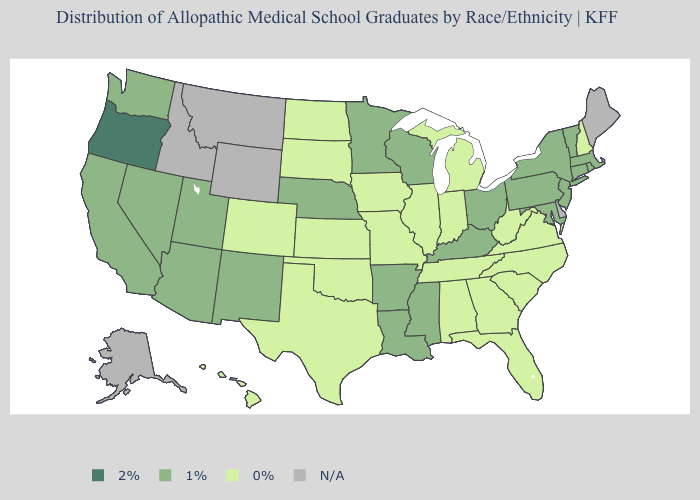What is the highest value in the USA?
Write a very short answer. 2%. What is the lowest value in the Northeast?
Be succinct. 0%. What is the value of Montana?
Be succinct. N/A. Does the first symbol in the legend represent the smallest category?
Concise answer only. No. What is the value of Wyoming?
Write a very short answer. N/A. What is the value of Massachusetts?
Write a very short answer. 1%. Does Missouri have the lowest value in the USA?
Give a very brief answer. Yes. Name the states that have a value in the range 0%?
Answer briefly. Alabama, Colorado, Florida, Georgia, Hawaii, Illinois, Indiana, Iowa, Kansas, Michigan, Missouri, New Hampshire, North Carolina, North Dakota, Oklahoma, South Carolina, South Dakota, Tennessee, Texas, Virginia, West Virginia. Does Colorado have the lowest value in the West?
Concise answer only. Yes. What is the value of Idaho?
Keep it brief. N/A. What is the highest value in states that border Utah?
Concise answer only. 1%. Is the legend a continuous bar?
Answer briefly. No. What is the value of Colorado?
Keep it brief. 0%. What is the lowest value in the USA?
Give a very brief answer. 0%. 